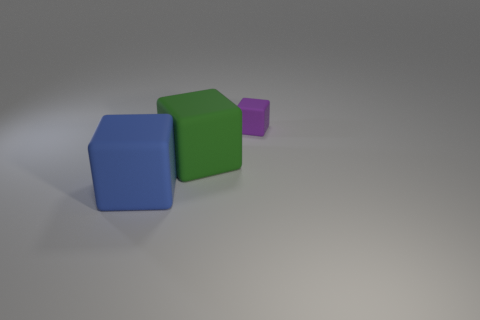Do the matte object that is left of the green block and the purple rubber object have the same size?
Keep it short and to the point. No. What number of objects have the same material as the large blue cube?
Your answer should be compact. 2. What is the big thing behind the large matte thing in front of the large cube that is behind the blue object made of?
Keep it short and to the point. Rubber. What color is the big matte block that is right of the big rubber thing in front of the large green object?
Give a very brief answer. Green. What is the color of the matte thing that is the same size as the green rubber cube?
Your answer should be compact. Blue. How many big things are either purple things or green rubber objects?
Ensure brevity in your answer.  1. Are there more green cubes that are to the right of the purple block than large cubes behind the large blue rubber block?
Ensure brevity in your answer.  No. What number of other things are there of the same size as the purple matte cube?
Offer a very short reply. 0. Is the block right of the green rubber object made of the same material as the blue cube?
Provide a succinct answer. Yes. How many other objects are the same color as the tiny matte block?
Your response must be concise. 0. 